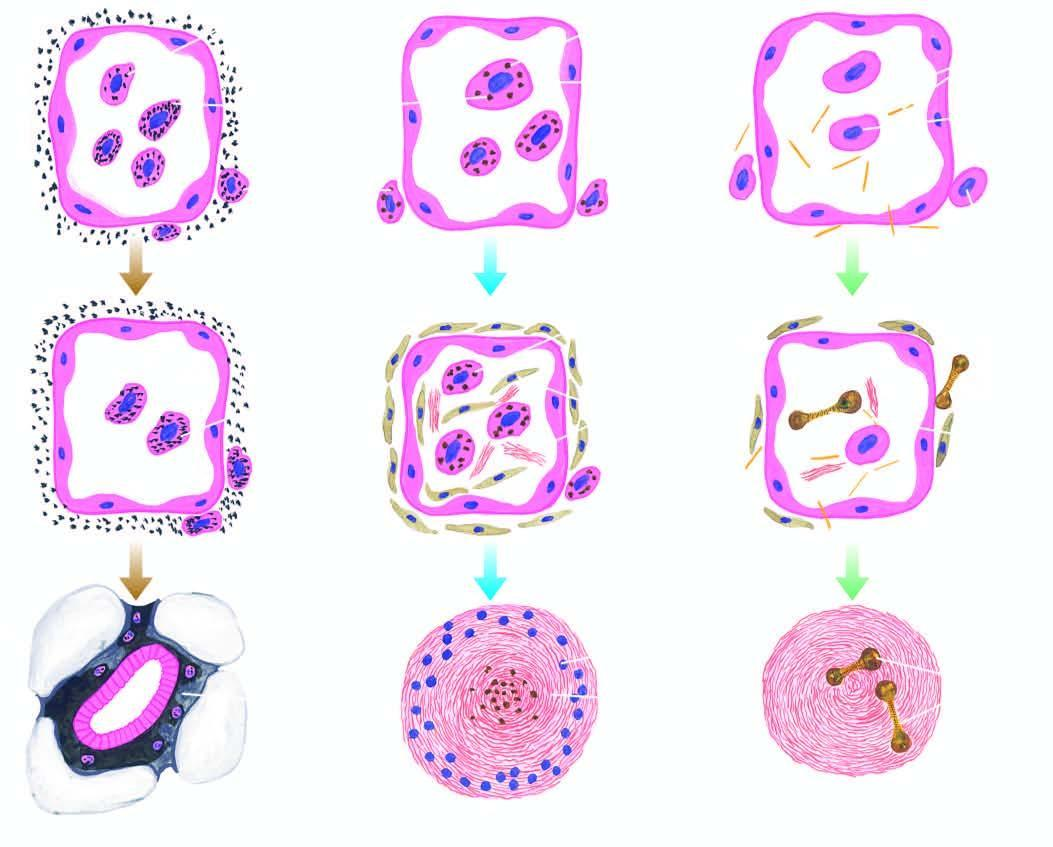s a giant cell with inclusions toxic to macrophages?
Answer the question using a single word or phrase. No 